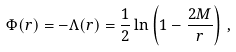<formula> <loc_0><loc_0><loc_500><loc_500>\Phi ( r ) = - \Lambda ( r ) = \frac { 1 } { 2 } \ln \left ( 1 - \frac { 2 M } { r } \right ) \, ,</formula> 